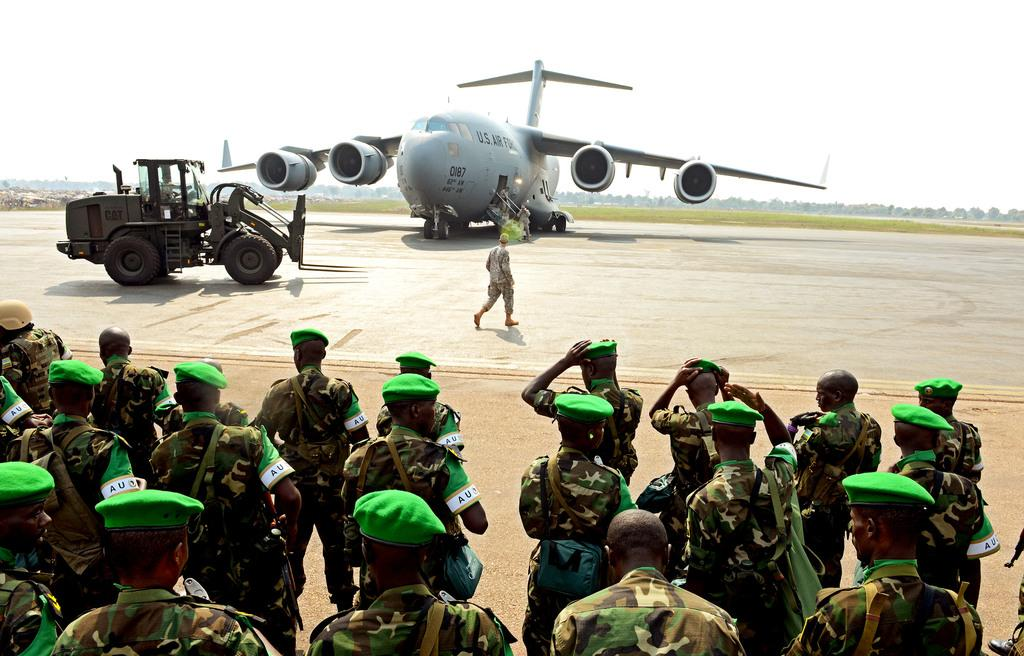How many people are present in the image? There are many people in the image. What are the people wearing on their heads? The people are wearing caps. What are the people holding in their hands? The people are holding bags. What can be seen in the background of the image? There is a flight in the background. What type of vehicle is visible in the image? There is a vehicle in the image. What is visible in the sky in the background? The sky is visible in the background. What type of sock is the creator wearing in the image? There is no creator present in the image, and therefore no sock can be observed. 